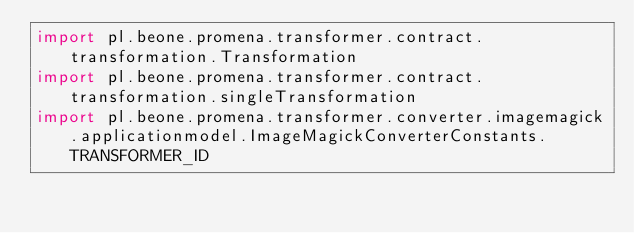<code> <loc_0><loc_0><loc_500><loc_500><_Kotlin_>import pl.beone.promena.transformer.contract.transformation.Transformation
import pl.beone.promena.transformer.contract.transformation.singleTransformation
import pl.beone.promena.transformer.converter.imagemagick.applicationmodel.ImageMagickConverterConstants.TRANSFORMER_ID</code> 